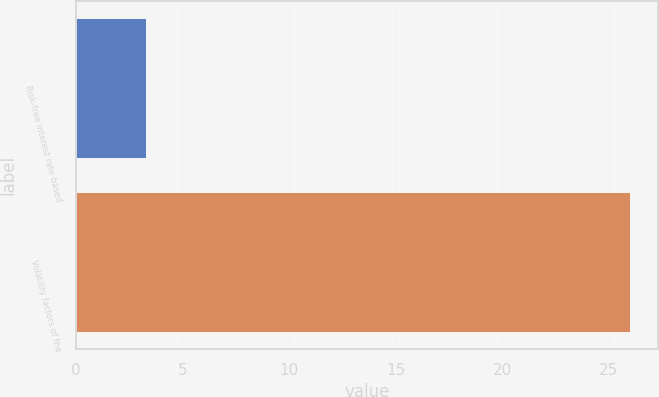<chart> <loc_0><loc_0><loc_500><loc_500><bar_chart><fcel>Risk-free interest rate based<fcel>Volatility factors of the<nl><fcel>3.29<fcel>26<nl></chart> 